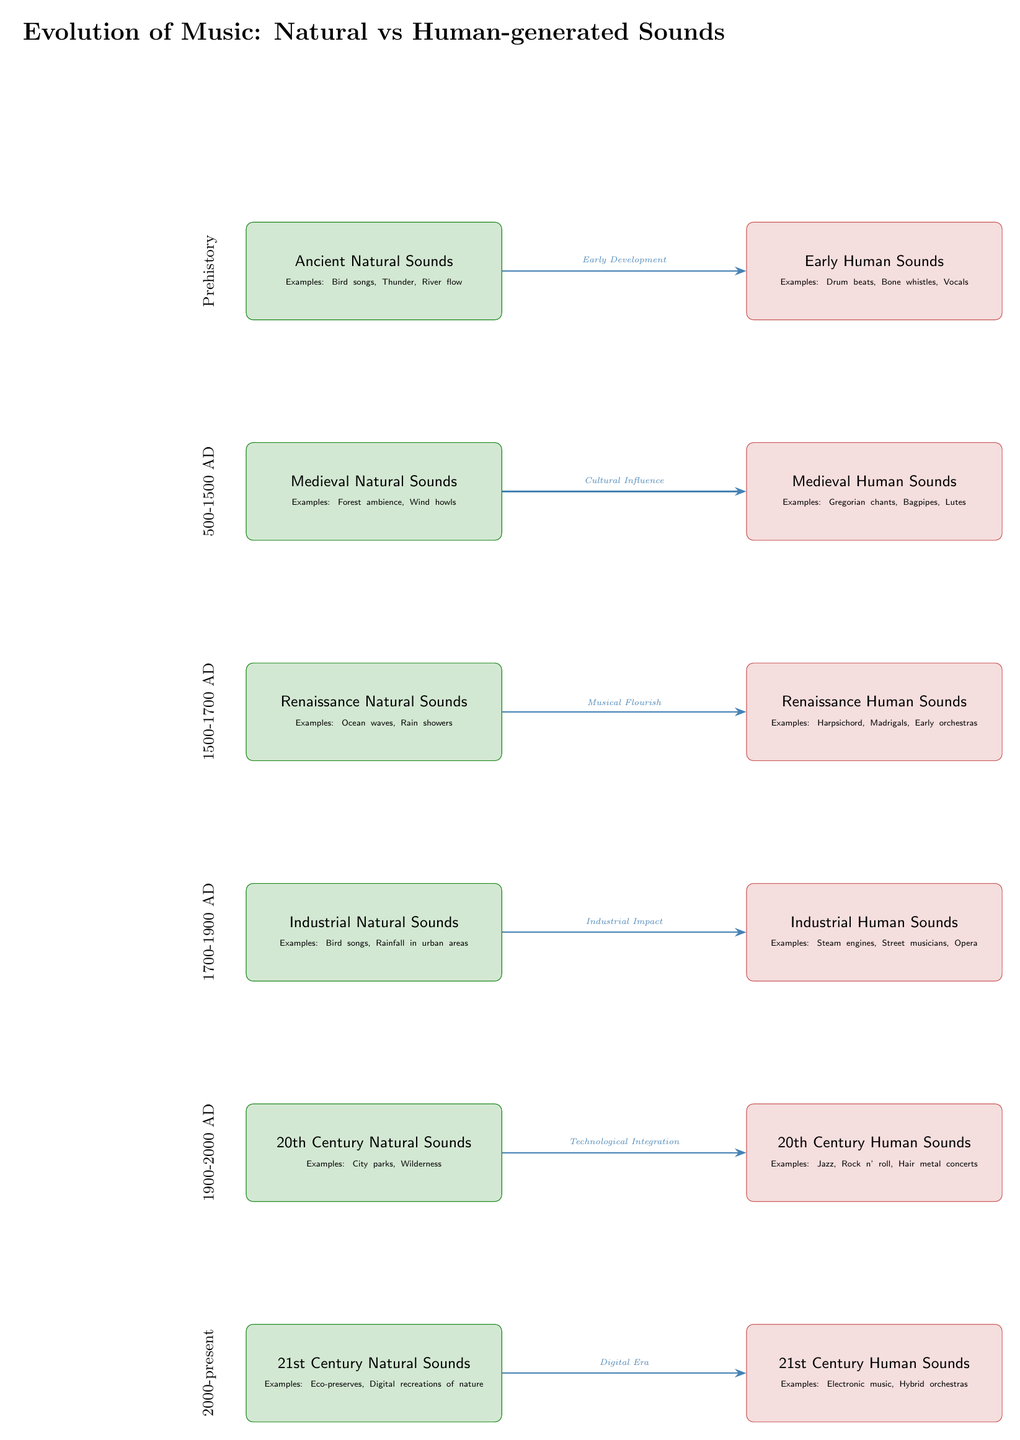What are examples of early human sounds? The diagram lists "Drum beats, Bone whistles, Vocals" as examples of early human sounds. These phrases can be found in the node labeled "Early Human Sounds" located to the right of "Ancient Natural Sounds."
Answer: Drum beats, Bone whistles, Vocals How many categories of sound are in the 20th Century? The diagram shows two categories of sound for the 20th Century: "20th Century Natural Sounds" and "20th Century Human Sounds." These categories can be counted from the nodes listed under the 20th Century in the diagram.
Answer: 2 What connects Medieval Human Sounds to Medieval Natural Sounds? The diagram indicates a connection labeled "Cultural Influence" between these two categories of sound. This connection is represented by an arrow that flows from the Medieval Natural Sounds node to the Medieval Human Sounds node.
Answer: Cultural Influence Which century has examples of eco-preserves? The "21st Century Natural Sounds" node includes "Eco-preserves" as an example, which is the bottom node in the 21st-century category of sound. Therefore, the answer is the 21st Century.
Answer: 21st Century What is a significant influence mentioned for Early Human Sounds? The connection to Early Human Sounds indicates "Early Development" as a significant influence, reflected in the arrow between "Ancient Natural Sounds" and "Early Human Sounds." This influence is noted in the labeling above the connecting arrow.
Answer: Early Development What do Industrial Human Sounds include? The diagram provides "Steam engines, Street musicians, Opera" as examples of Industrial Human Sounds, which can be located in the node specifically labeled for this category.
Answer: Steam engines, Street musicians, Opera What type of music is associated with the 20th Century? The node titled "20th Century Human Sounds" lists "Jazz, Rock n' roll, Hair metal concerts" as types of music in this period, making this the answer.
Answer: Jazz, Rock n' roll, Hair metal concerts What is the period classified as 500-1500 AD primarily showing? The years 500-1500 AD fall under the Medieval sounds category in the diagram, which shows "Medieval Natural Sounds" and "Medieval Human Sounds." From this, we identify that this classification uniquely denotes the medieval period's sounds.
Answer: Medieval sounds 